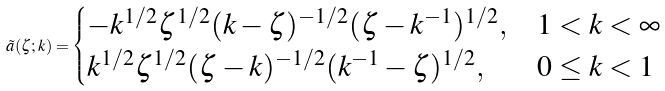Convert formula to latex. <formula><loc_0><loc_0><loc_500><loc_500>\tilde { a } ( \zeta ; k ) = \begin{cases} - k ^ { 1 / 2 } \zeta ^ { 1 / 2 } ( k - \zeta ) ^ { - 1 / 2 } ( \zeta - k ^ { - 1 } ) ^ { 1 / 2 } , & 1 < k < \infty \\ k ^ { 1 / 2 } \zeta ^ { 1 / 2 } ( \zeta - k ) ^ { - 1 / 2 } ( k ^ { - 1 } - \zeta ) ^ { 1 / 2 } , & 0 \leq k < 1 \end{cases}</formula> 